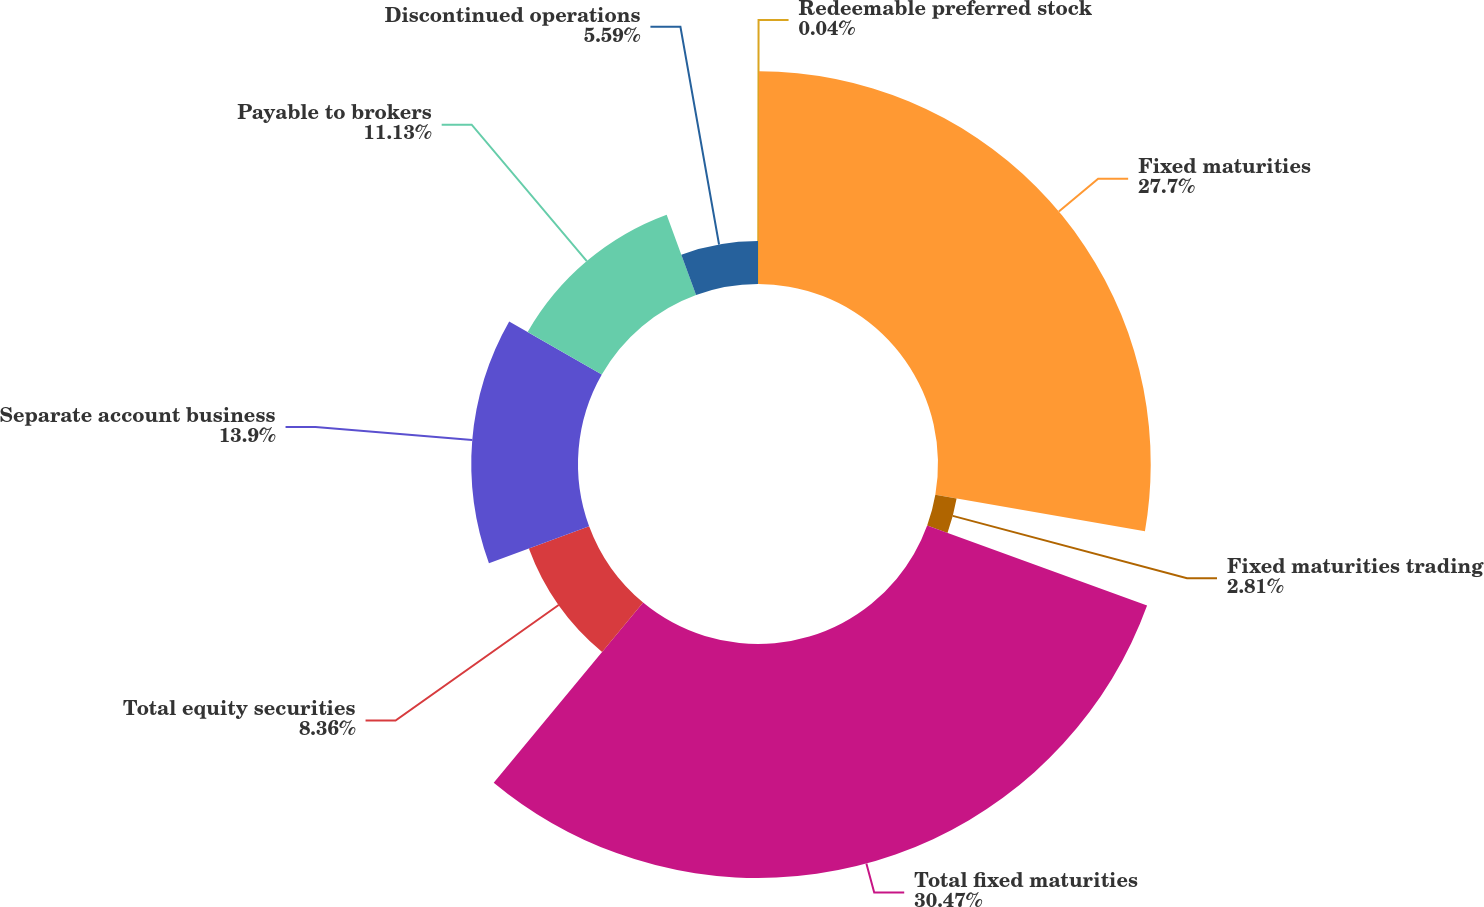Convert chart to OTSL. <chart><loc_0><loc_0><loc_500><loc_500><pie_chart><fcel>Redeemable preferred stock<fcel>Fixed maturities<fcel>Fixed maturities trading<fcel>Total fixed maturities<fcel>Total equity securities<fcel>Separate account business<fcel>Payable to brokers<fcel>Discontinued operations<nl><fcel>0.04%<fcel>27.7%<fcel>2.81%<fcel>30.47%<fcel>8.36%<fcel>13.9%<fcel>11.13%<fcel>5.59%<nl></chart> 